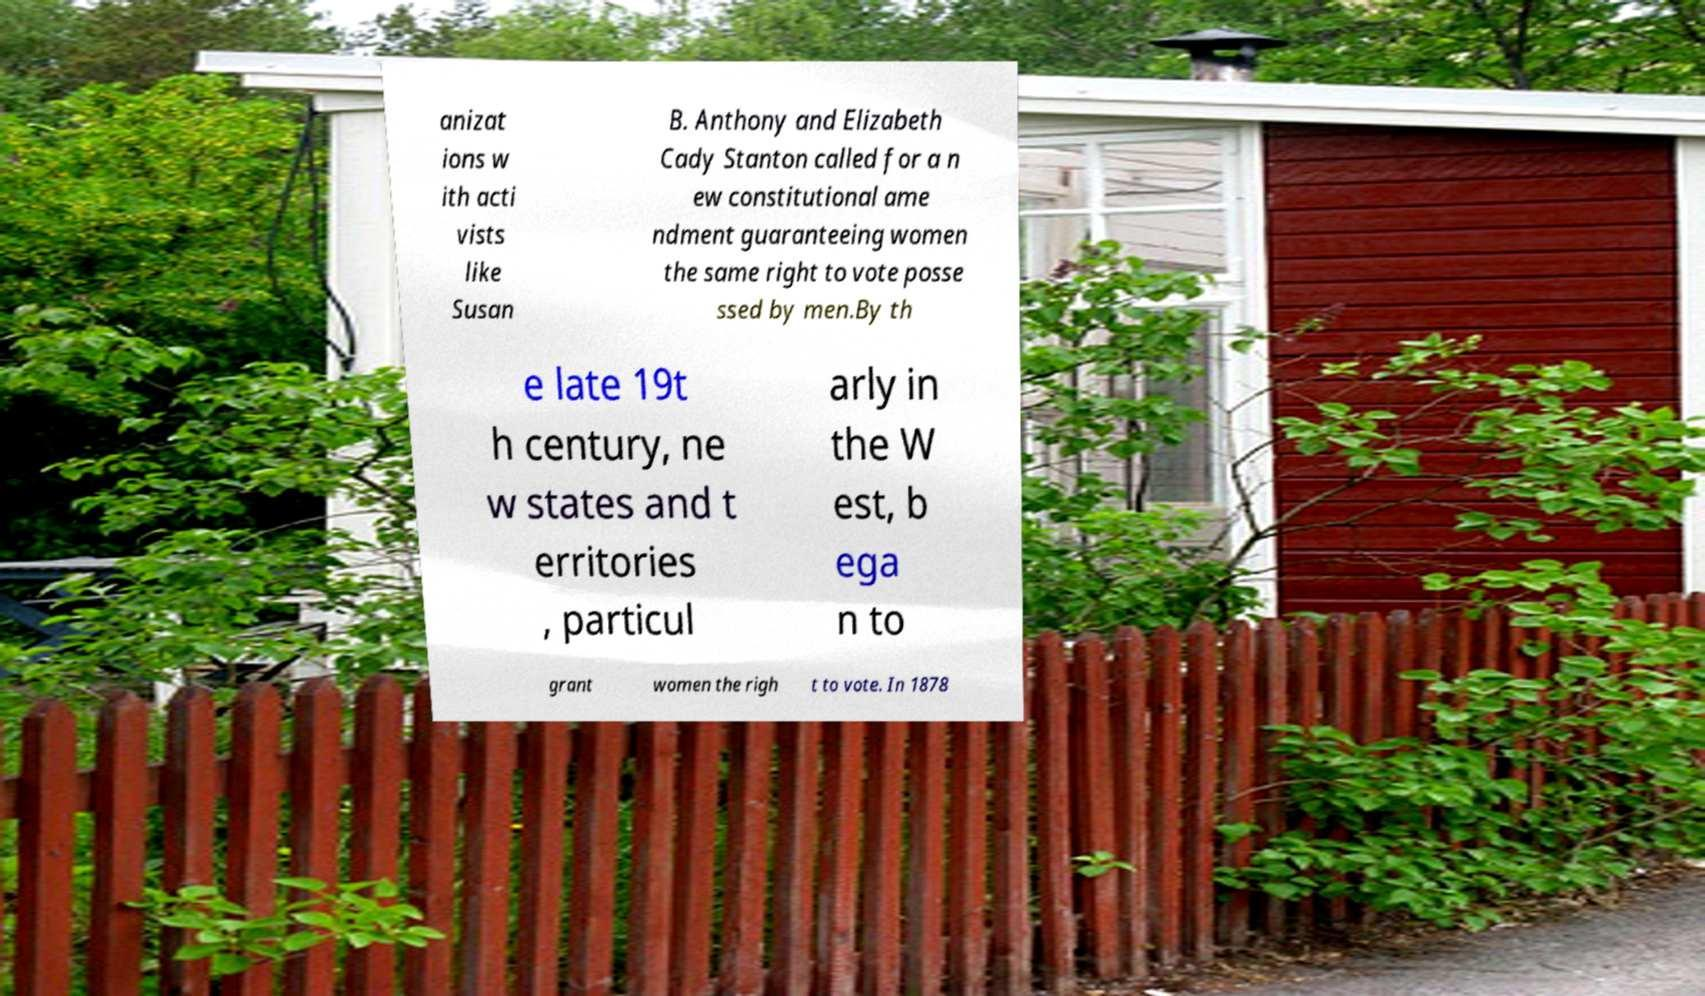Can you accurately transcribe the text from the provided image for me? anizat ions w ith acti vists like Susan B. Anthony and Elizabeth Cady Stanton called for a n ew constitutional ame ndment guaranteeing women the same right to vote posse ssed by men.By th e late 19t h century, ne w states and t erritories , particul arly in the W est, b ega n to grant women the righ t to vote. In 1878 